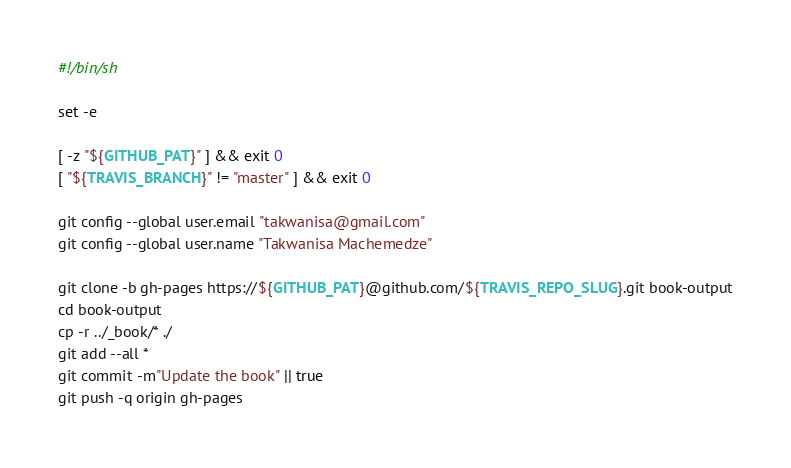<code> <loc_0><loc_0><loc_500><loc_500><_Bash_>#!/bin/sh

set -e

[ -z "${GITHUB_PAT}" ] && exit 0
[ "${TRAVIS_BRANCH}" != "master" ] && exit 0

git config --global user.email "takwanisa@gmail.com"
git config --global user.name "Takwanisa Machemedze"

git clone -b gh-pages https://${GITHUB_PAT}@github.com/${TRAVIS_REPO_SLUG}.git book-output
cd book-output
cp -r ../_book/* ./
git add --all *
git commit -m"Update the book" || true
git push -q origin gh-pages
</code> 